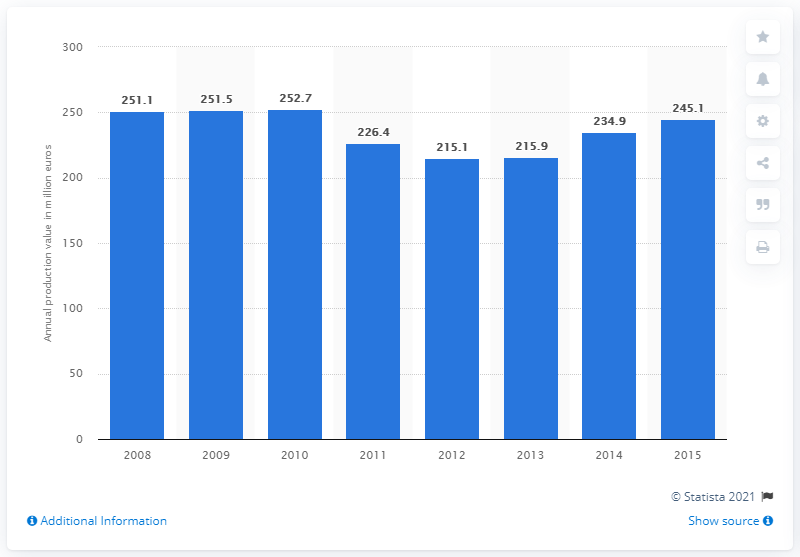Identify some key points in this picture. In 2015, the production value of the soap and detergents manufacturing industry in Denmark was 245.1 Million DKK. 